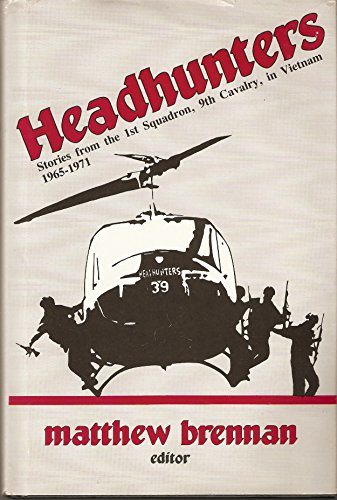Is this book related to History? Yes, this book is deeply rooted in history, providing firsthand accounts and an in-depth look at the 1st Squadron, 9th Cavalry's operations during a critical period of the Vietnam War. 